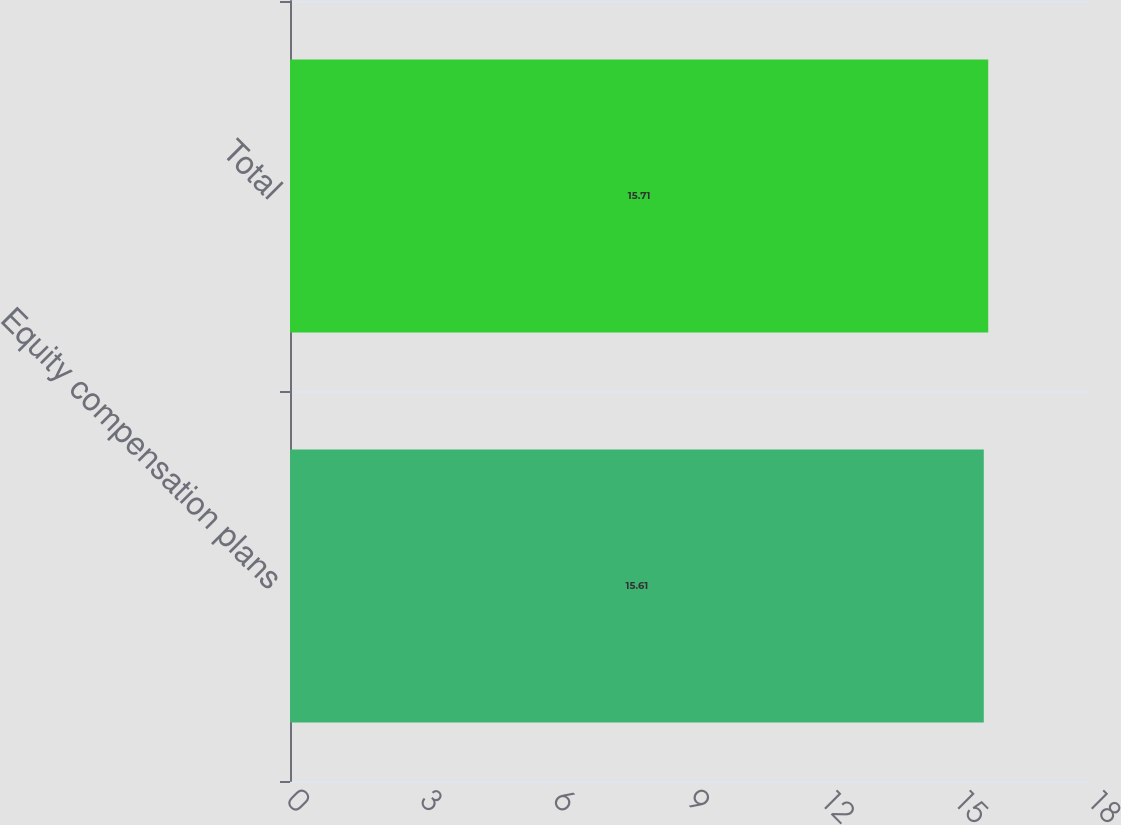Convert chart to OTSL. <chart><loc_0><loc_0><loc_500><loc_500><bar_chart><fcel>Equity compensation plans<fcel>Total<nl><fcel>15.61<fcel>15.71<nl></chart> 